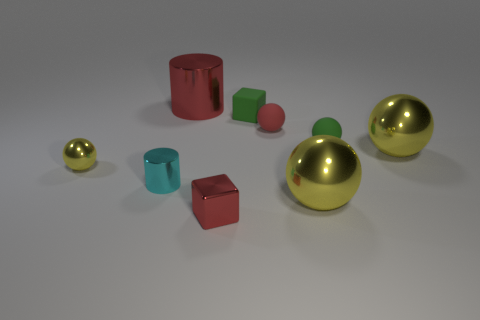How many yellow spheres must be subtracted to get 1 yellow spheres? 2 Subtract all red spheres. How many spheres are left? 4 Subtract all red balls. How many balls are left? 4 Subtract all green blocks. How many red cylinders are left? 1 Subtract all metal blocks. Subtract all red metallic cylinders. How many objects are left? 7 Add 3 red rubber spheres. How many red rubber spheres are left? 4 Add 1 small metallic things. How many small metallic things exist? 4 Add 1 purple rubber cubes. How many objects exist? 10 Subtract 0 purple blocks. How many objects are left? 9 Subtract all cylinders. How many objects are left? 7 